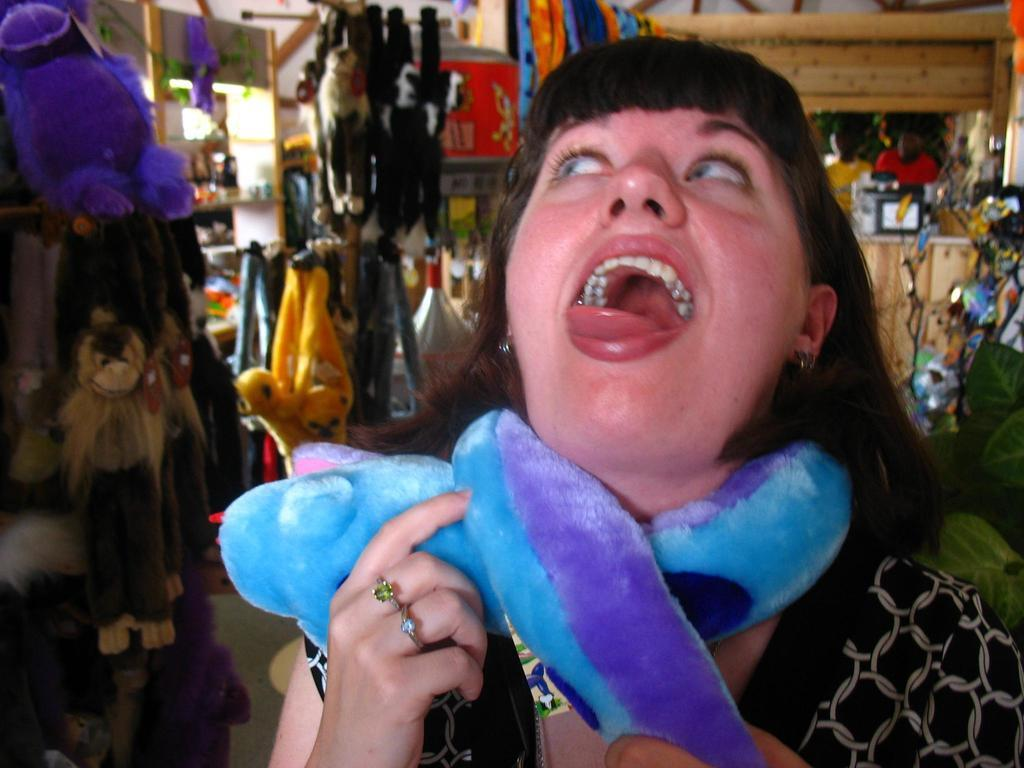Who is the main subject in the image? There is a lady in the image. What is the lady holding in the image? The lady is holding a soft toy. What else can be seen in the background of the image? There are toys and people visible in the background of the image. Where is the plant located in the image? There is a plant on the right side of the image. What type of voice can be heard coming from the lady in the image? There is no indication of any voice or sound in the image, so it is not possible to determine what type of voice might be heard. 